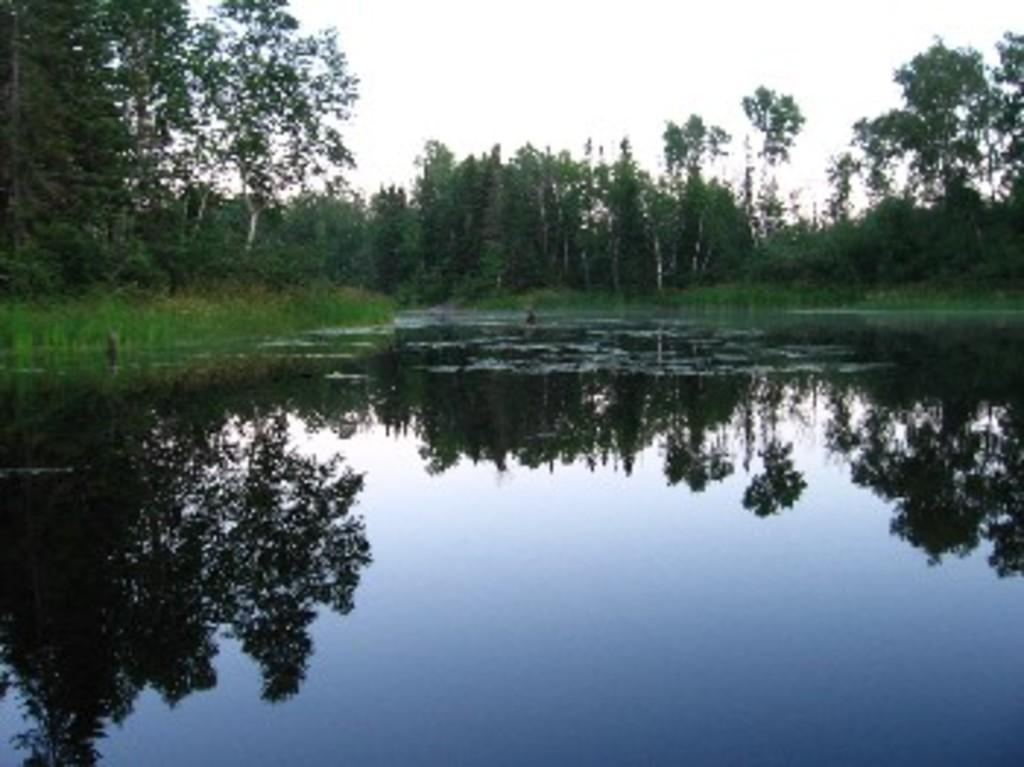What is at the bottom of the image? There is water at the bottom of the image. What type of vegetation is present on the ground behind the water? There is grass on the ground behind the water. What can be seen in the distance in the image? There are trees in the background of the image. What is visible at the top of the image? The sky is visible at the top of the image. How many lizards are crawling on the thing in the image? There are no lizards or things present in the image. What type of spring is visible in the image? There is no spring present in the image. 